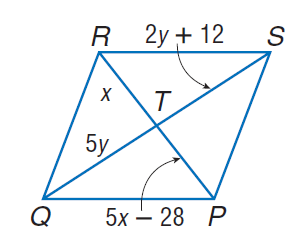Question: Find x so that the quadrilateral is a parallelogram.
Choices:
A. 7
B. 14
C. 21
D. 35
Answer with the letter. Answer: A 